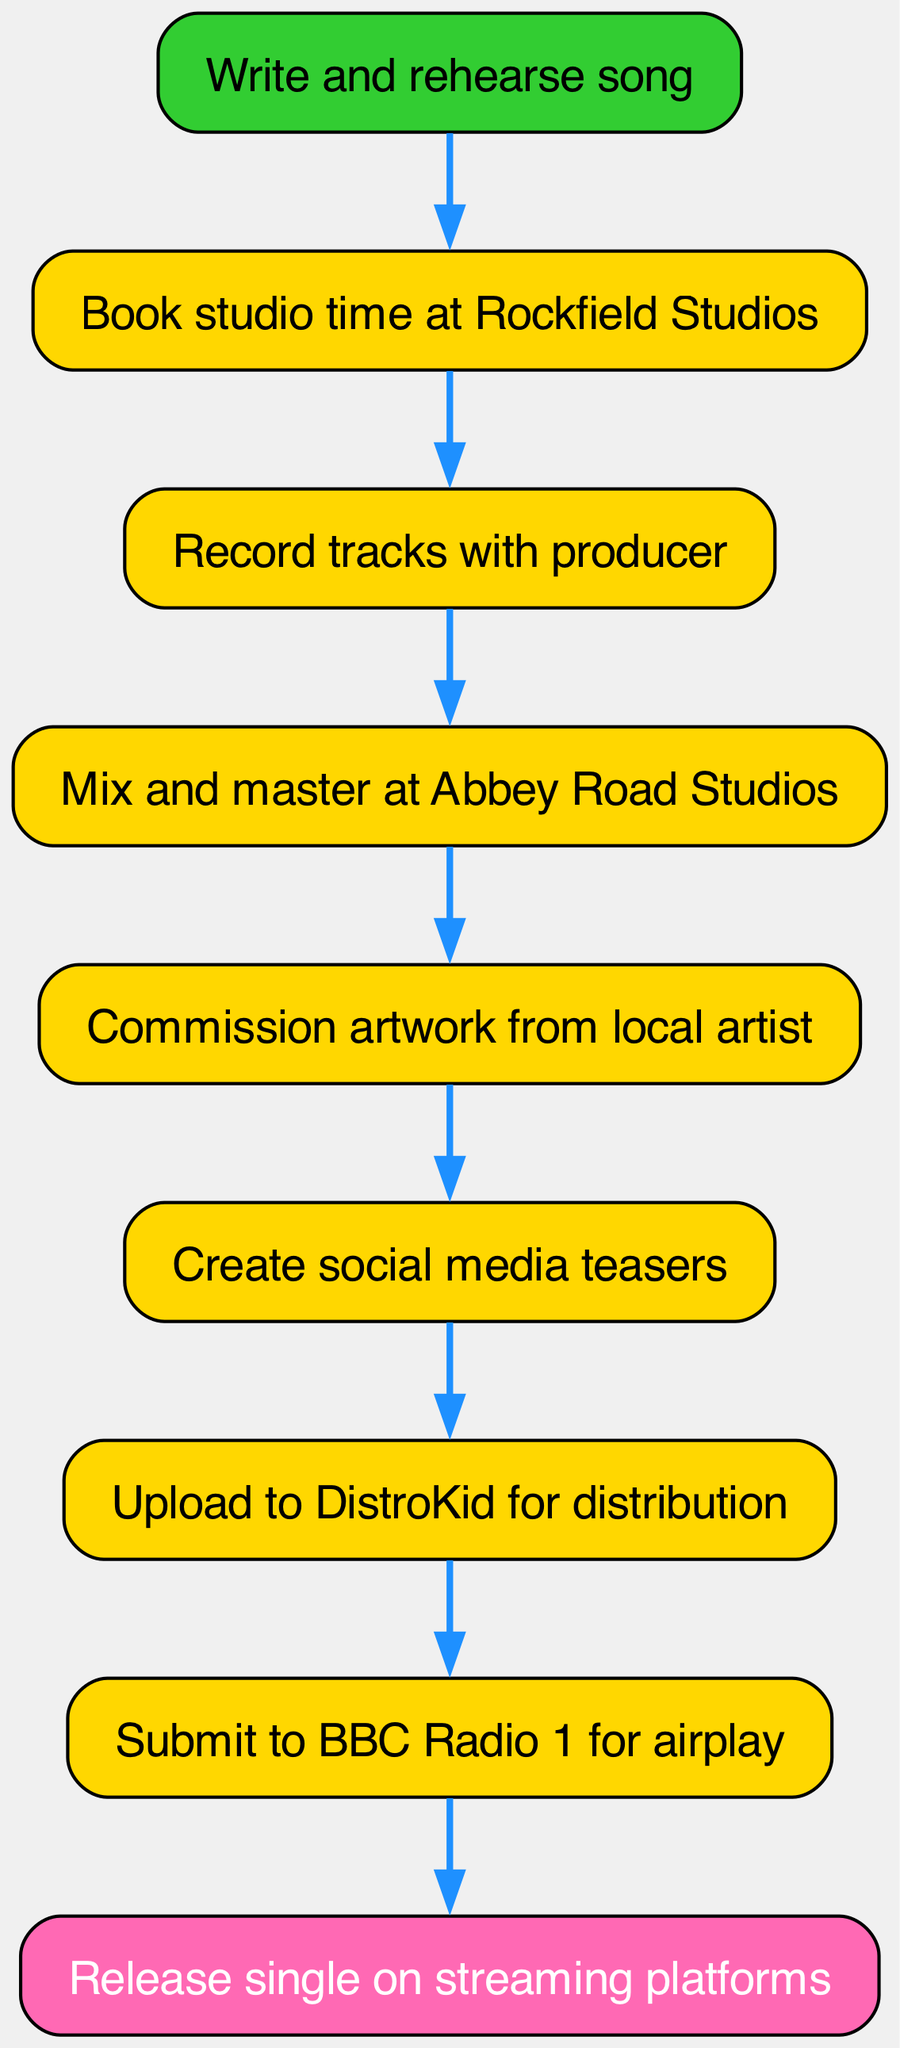What is the first step in releasing a single? The first step in the process is to "Write and rehearse song." This is found at the top of the flow chart as the initial node.
Answer: Write and rehearse song How many steps are there in the process? By counting the nodes in the flow chart, there are a total of nine distinct steps from writing the song to releasing it on streaming platforms.
Answer: Nine Which studio is used for mixing and mastering? The mixing and mastering takes place at "Abbey Road Studios." This is indicated in the fourth step of the diagram.
Answer: Abbey Road Studios What action occurs after creating social media teasers? After creating social media teasers, the next step is to "Upload to DistroKid for distribution." This relationship can be traced from the sixth step to the seventh step in the flow chart.
Answer: Upload to DistroKid for distribution Which step comes immediately before the release on streaming platforms? The step that comes immediately before releasing the single on streaming platforms is "Submit to BBC Radio 1 for airplay." This can be found in the eighth step of the diagram.
Answer: Submit to BBC Radio 1 for airplay What is the last node in the flow chart? The last node in the flow chart represents the final action: "Release single on streaming platforms." This is clearly marked as the ninth step and concludes the process.
Answer: Release single on streaming platforms How does the process flow from recording tracks to mixing? The process flows from "Record tracks with producer" to "Mix and master at Abbey Road Studios." This connection is shown through the edge linking the third step to the fourth step in the diagram.
Answer: Mix and master at Abbey Road Studios 